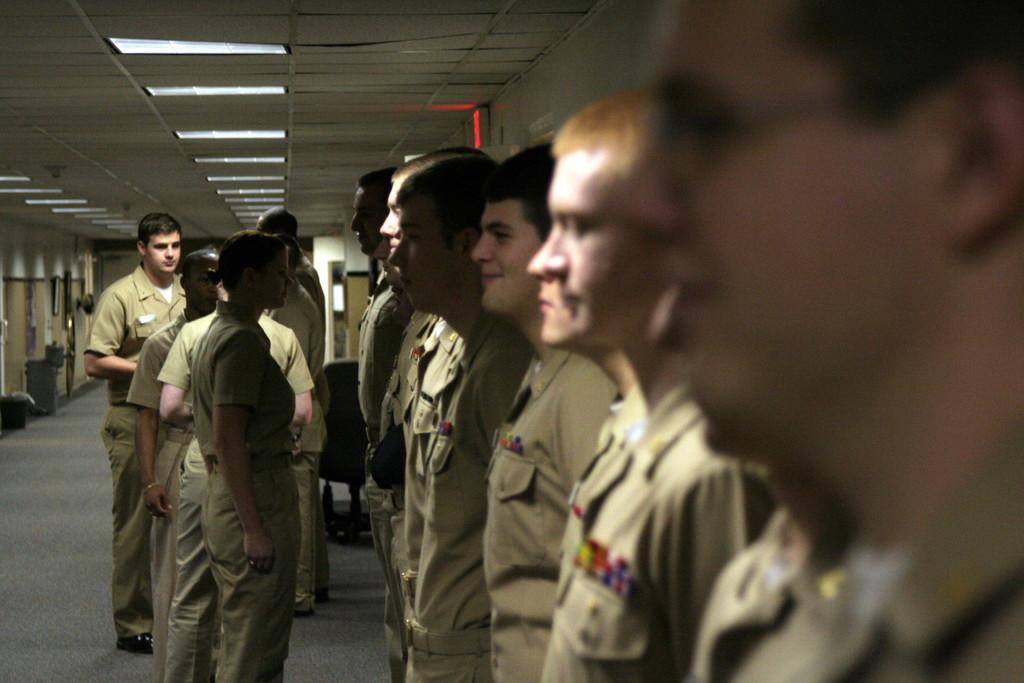Please provide a concise description of this image. In this image can see many persons standing on the floor. In the background we can see chair, photo frames, wall and lights. 